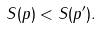<formula> <loc_0><loc_0><loc_500><loc_500>S ( p ) < S ( p ^ { \prime } ) .</formula> 